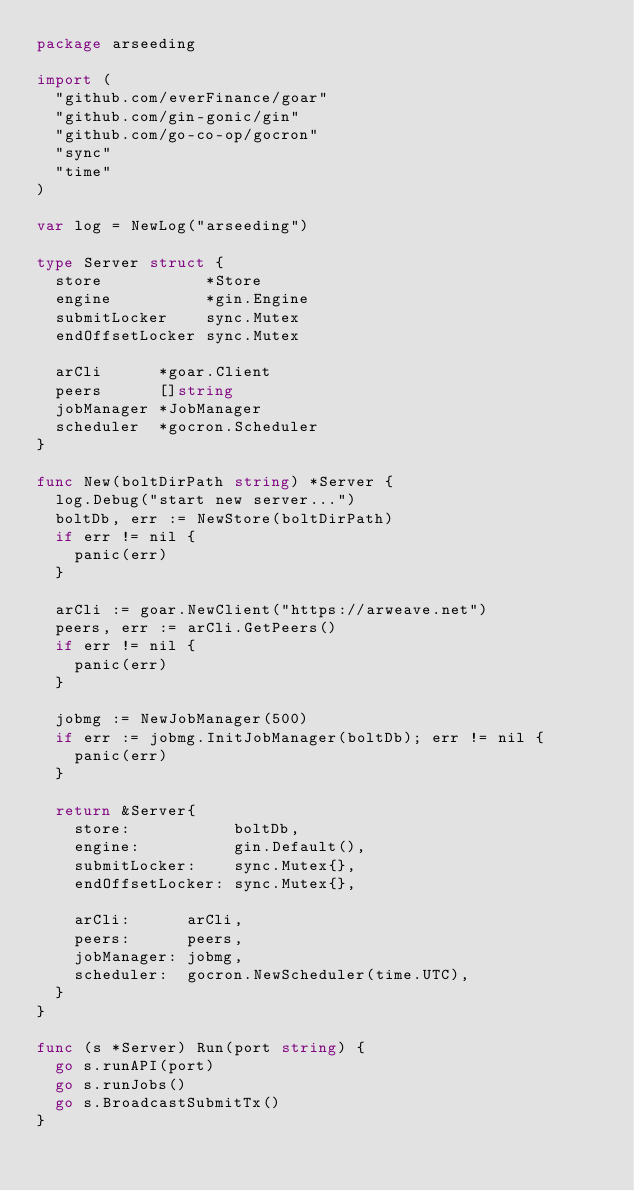<code> <loc_0><loc_0><loc_500><loc_500><_Go_>package arseeding

import (
	"github.com/everFinance/goar"
	"github.com/gin-gonic/gin"
	"github.com/go-co-op/gocron"
	"sync"
	"time"
)

var log = NewLog("arseeding")

type Server struct {
	store           *Store
	engine          *gin.Engine
	submitLocker    sync.Mutex
	endOffsetLocker sync.Mutex

	arCli      *goar.Client
	peers      []string
	jobManager *JobManager
	scheduler  *gocron.Scheduler
}

func New(boltDirPath string) *Server {
	log.Debug("start new server...")
	boltDb, err := NewStore(boltDirPath)
	if err != nil {
		panic(err)
	}

	arCli := goar.NewClient("https://arweave.net")
	peers, err := arCli.GetPeers()
	if err != nil {
		panic(err)
	}

	jobmg := NewJobManager(500)
	if err := jobmg.InitJobManager(boltDb); err != nil {
		panic(err)
	}

	return &Server{
		store:           boltDb,
		engine:          gin.Default(),
		submitLocker:    sync.Mutex{},
		endOffsetLocker: sync.Mutex{},

		arCli:      arCli,
		peers:      peers,
		jobManager: jobmg,
		scheduler:  gocron.NewScheduler(time.UTC),
	}
}

func (s *Server) Run(port string) {
	go s.runAPI(port)
	go s.runJobs()
	go s.BroadcastSubmitTx()
}
</code> 